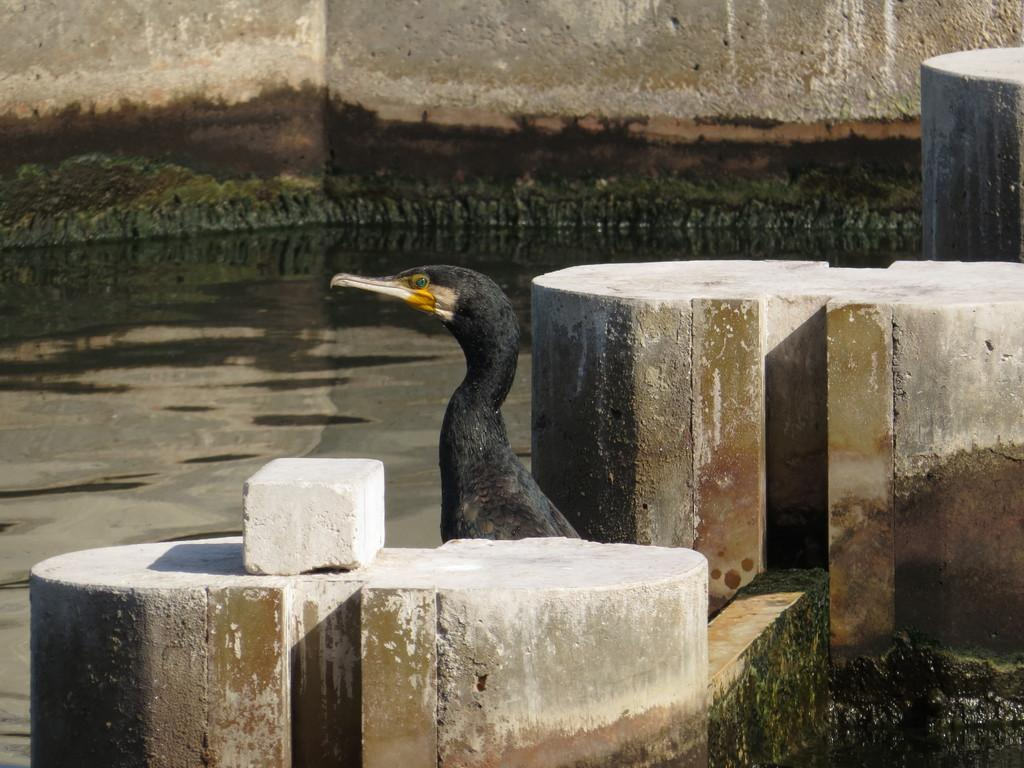What type of animal can be seen in the image? There is a bird in the image. What colors are present on the bird? The bird has black and yellow colors. What type of seating is visible in the image? There are cement benches in the image. What is the background of the image made of? There is a wall in the image. What natural element is visible in the image? There is water visible in the image. What type of organization is being held in the image? There is no indication of an organization in the image; it primarily features a bird and some man-made elements. 